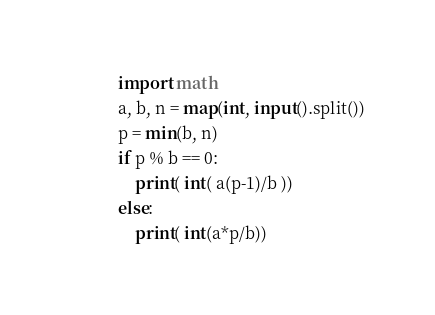<code> <loc_0><loc_0><loc_500><loc_500><_Python_>import math
a, b, n = map(int, input().split())
p = min(b, n)
if p % b == 0:
    print( int( a(p-1)/b ))
else:
    print( int(a*p/b))</code> 